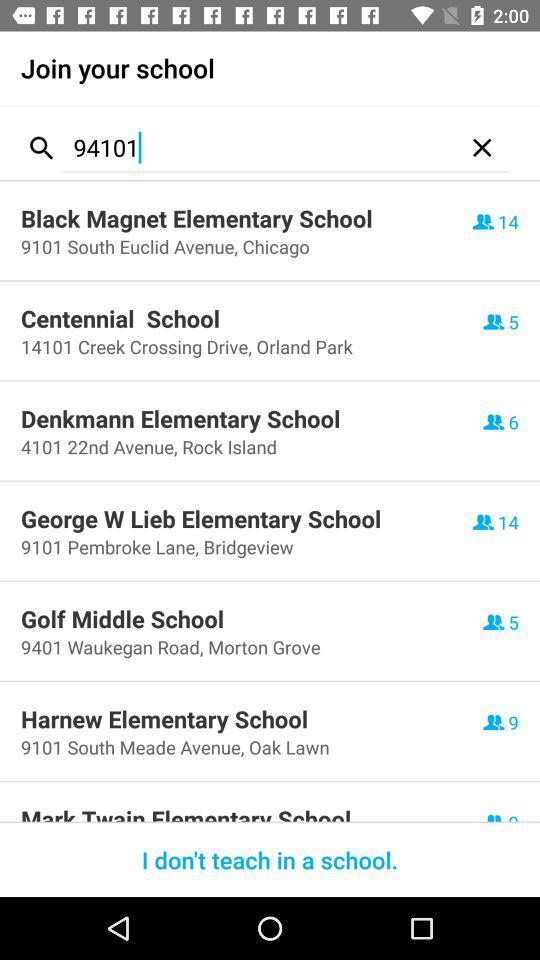Which school is located in Chicago? The school that is located in Chicago is Black Magnet Elementary School. 